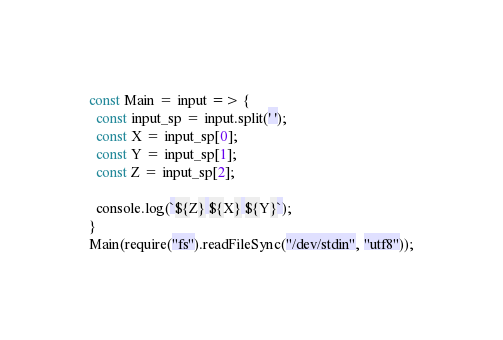<code> <loc_0><loc_0><loc_500><loc_500><_JavaScript_>const Main = input => {
  const input_sp = input.split(' ');
  const X = input_sp[0];
  const Y = input_sp[1];
  const Z = input_sp[2];

  console.log(`${Z} ${X} ${Y}`);
}
Main(require("fs").readFileSync("/dev/stdin", "utf8"));
</code> 